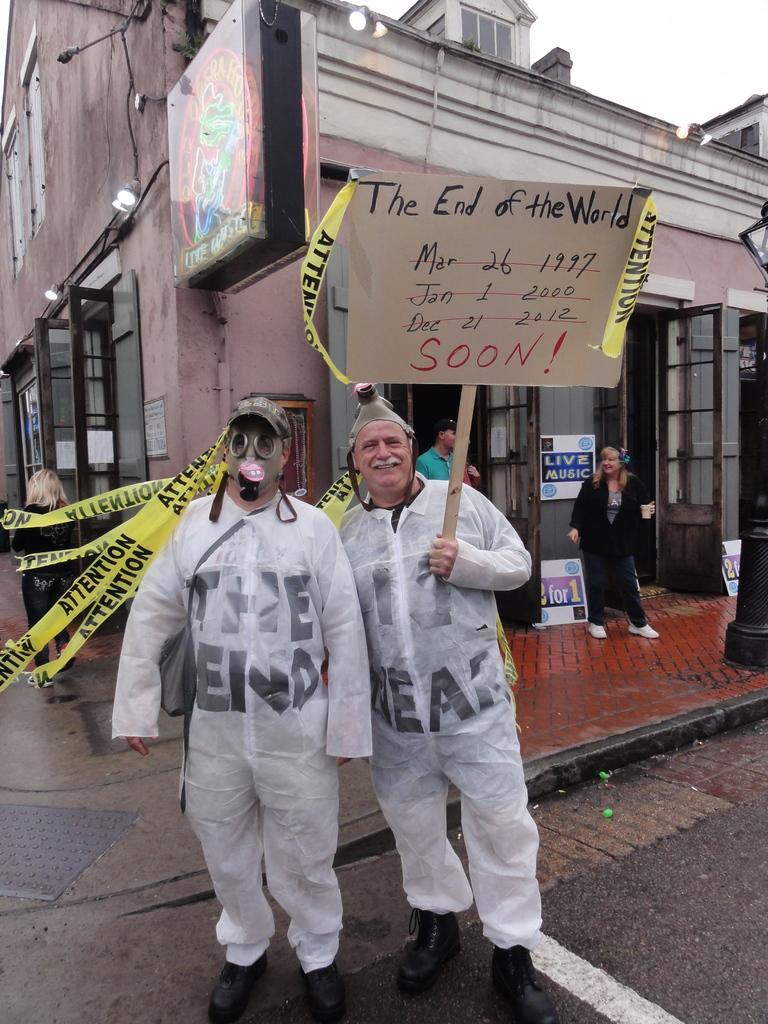In one or two sentences, can you explain what this image depicts? In this picture we can see a cap, poster and two people standing on the road and at the back of them we can see buildings, windows, doors, posters, lights, board, some people and some objects. 